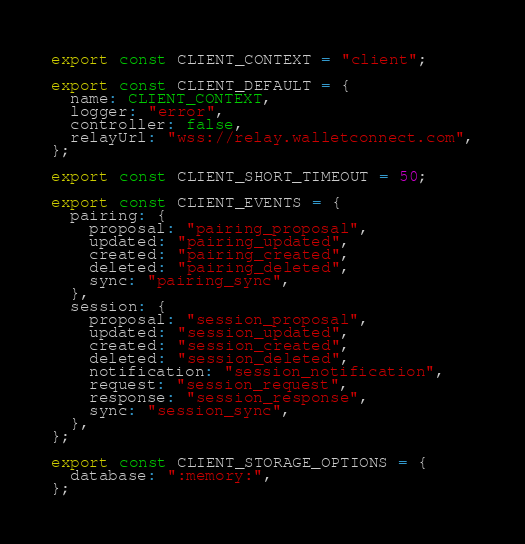Convert code to text. <code><loc_0><loc_0><loc_500><loc_500><_TypeScript_>export const CLIENT_CONTEXT = "client";

export const CLIENT_DEFAULT = {
  name: CLIENT_CONTEXT,
  logger: "error",
  controller: false,
  relayUrl: "wss://relay.walletconnect.com",
};

export const CLIENT_SHORT_TIMEOUT = 50;

export const CLIENT_EVENTS = {
  pairing: {
    proposal: "pairing_proposal",
    updated: "pairing_updated",
    created: "pairing_created",
    deleted: "pairing_deleted",
    sync: "pairing_sync",
  },
  session: {
    proposal: "session_proposal",
    updated: "session_updated",
    created: "session_created",
    deleted: "session_deleted",
    notification: "session_notification",
    request: "session_request",
    response: "session_response",
    sync: "session_sync",
  },
};

export const CLIENT_STORAGE_OPTIONS = {
  database: ":memory:",
};
</code> 